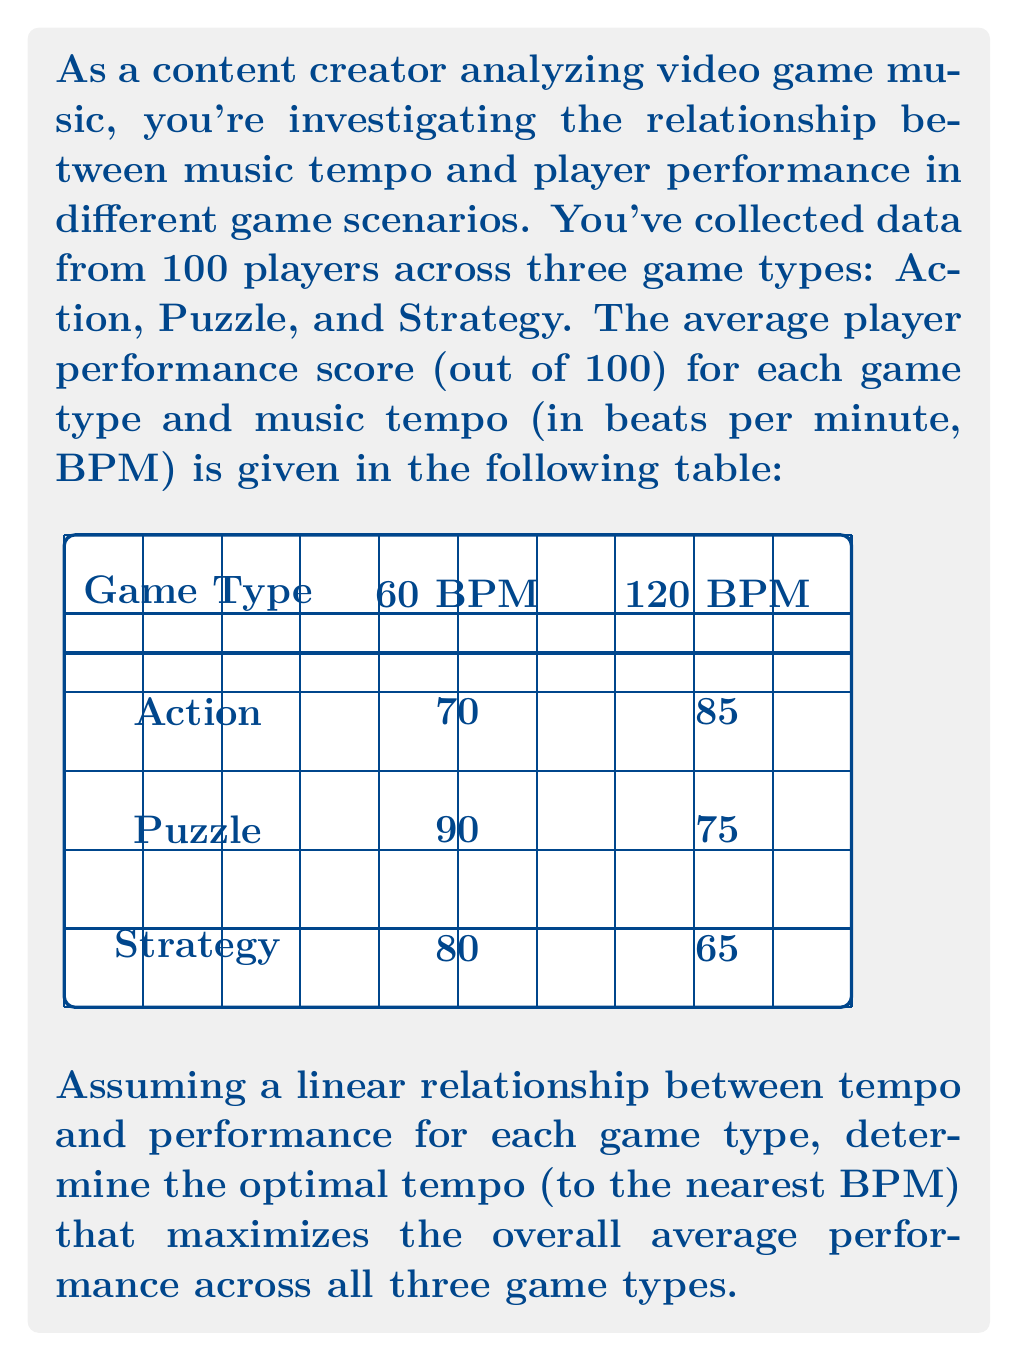Show me your answer to this math problem. Let's approach this step-by-step:

1) First, we need to find the linear relationship between tempo and performance for each game type. We can use the point-slope form of a line: $y - y_1 = m(x - x_1)$, where $m$ is the slope.

2) For each game type, we can calculate the slope:

   Action: $m_a = \frac{85-70}{120-60} = \frac{15}{60} = 0.25$
   Puzzle: $m_p = \frac{75-90}{120-60} = -0.25$
   Strategy: $m_s = \frac{65-80}{120-60} = -0.25$

3) Now we can write equations for each game type:

   Action: $y_a = 0.25x + 55$
   Puzzle: $y_p = -0.25x + 105$
   Strategy: $y_s = -0.25x + 95$

4) To maximize overall performance, we need to maximize the average of these three equations:

   $y_{avg} = \frac{y_a + y_p + y_s}{3} = \frac{(0.25x + 55) + (-0.25x + 105) + (-0.25x + 95)}{3}$

5) Simplifying:

   $y_{avg} = \frac{-0.25x + 255}{3} = -\frac{1}{12}x + 85$

6) To find the maximum of this linear function, we need to consider the domain constraints. Tempo is typically between 60 and 180 BPM.

7) Since the coefficient of $x$ is negative, the maximum will occur at the lower bound of the domain, which is 60 BPM.

8) Rounding to the nearest BPM, the optimal tempo is 60 BPM.
Answer: 60 BPM 